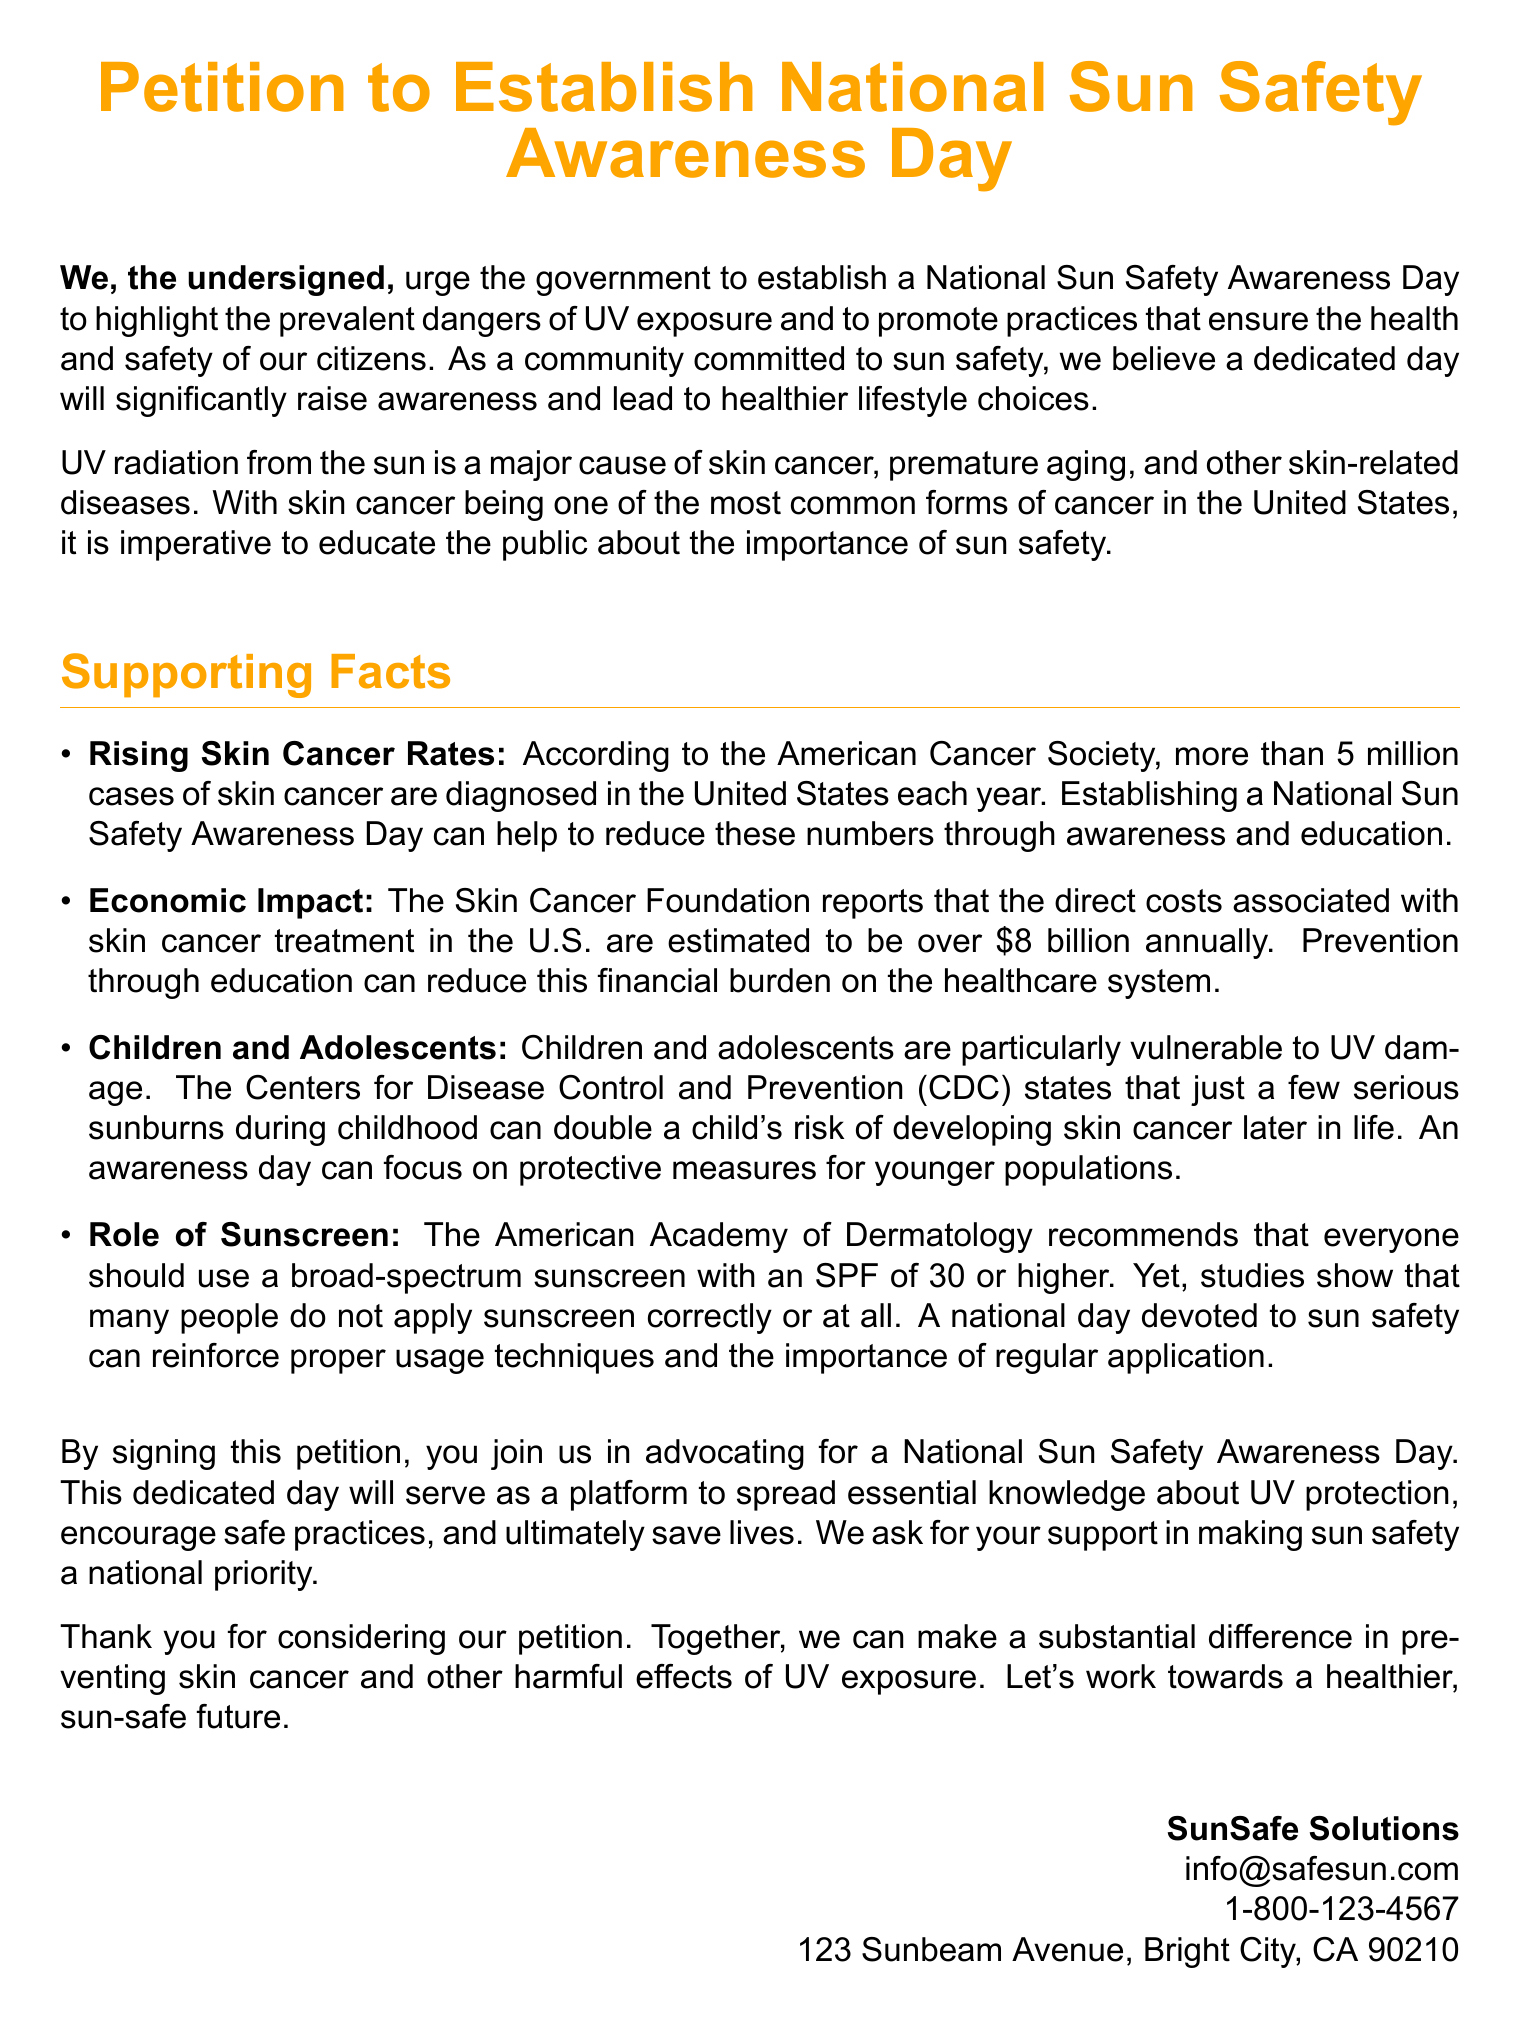What is the title of the petition? The title of the petition is explicitly stated at the top of the document, indicating its purpose.
Answer: Petition to Establish National Sun Safety Awareness Day How many million cases of skin cancer are diagnosed in the U.S. each year? The document mentions this statistic to emphasize the urgency for awareness and prevention.
Answer: 5 million What is the estimated annual direct cost of skin cancer treatment in the U.S.? This figure is provided to highlight the economic burden of skin cancer treatment.
Answer: 8 billion Which organization reports the statistic about serious sunburns in childhood? The source of information regarding children's vulnerability to UV damage is specified in the document.
Answer: Centers for Disease Control and Prevention What does the American Academy of Dermatology recommend for sunscreen? The recommendation includes details on the type and strength of sunscreen necessary for protection.
Answer: Broad-spectrum sunscreen with an SPF of 30 or higher Why do children and adolescents need special focus in sun safety awareness? This question implies reasoning about the connection between early sun exposure and long-term cancer risk, as outlined in the document.
Answer: They are particularly vulnerable to UV damage What is the role of the petition in advocating for sun safety? The petition serves as a call to action, encouraging collective advocacy for an awareness day, which is clarified in the document.
Answer: Advocate for a National Sun Safety Awareness Day Where should support inquiries for the petition be directed? Contact information at the bottom of the document indicates how to reach the organization.
Answer: info@safesun.com 